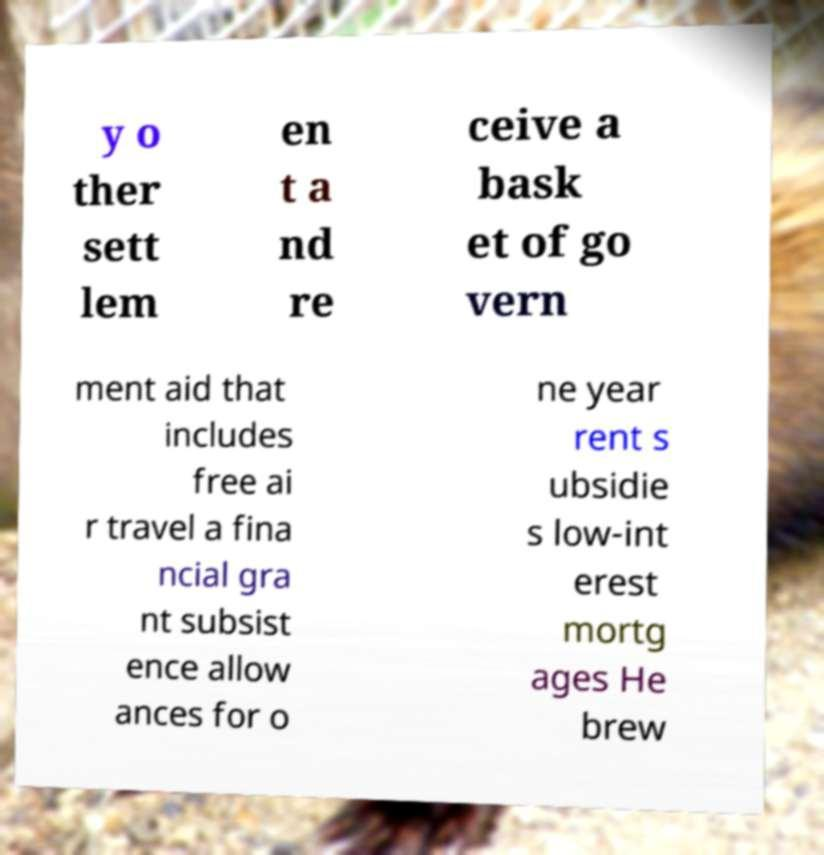Please identify and transcribe the text found in this image. y o ther sett lem en t a nd re ceive a bask et of go vern ment aid that includes free ai r travel a fina ncial gra nt subsist ence allow ances for o ne year rent s ubsidie s low-int erest mortg ages He brew 